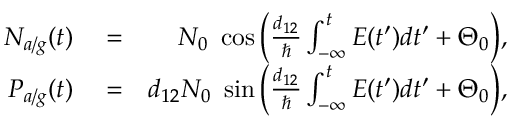Convert formula to latex. <formula><loc_0><loc_0><loc_500><loc_500>\begin{array} { r l r } { N _ { a / g } ( t ) } & = } & { N _ { 0 } \ \cos \left ( \frac { d _ { 1 2 } } { } \int _ { - \infty } ^ { t } E ( t ^ { \prime } ) d t ^ { \prime } + \Theta _ { 0 } \right ) , } \\ { P _ { a / g } ( t ) } & = } & { d _ { 1 2 } N _ { 0 } \ \sin \left ( \frac { d _ { 1 2 } } { } \int _ { - \infty } ^ { t } E ( t ^ { \prime } ) d t ^ { \prime } + \Theta _ { 0 } \right ) , } \end{array}</formula> 